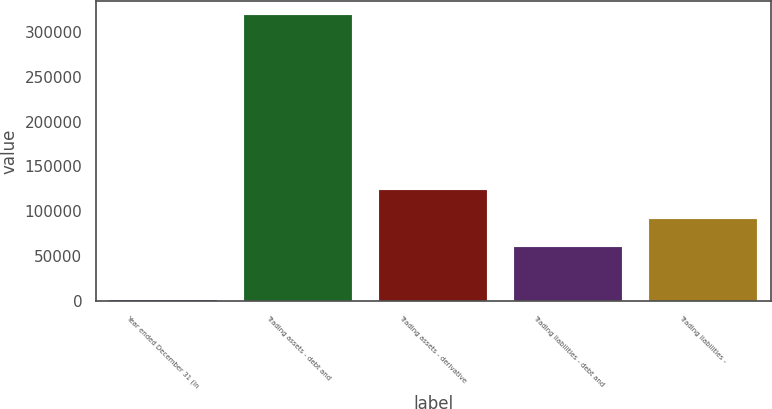Convert chart. <chart><loc_0><loc_0><loc_500><loc_500><bar_chart><fcel>Year ended December 31 (in<fcel>Trading assets - debt and<fcel>Trading assets - derivative<fcel>Trading liabilities - debt and<fcel>Trading liabilities -<nl><fcel>2009<fcel>318063<fcel>123435<fcel>60224<fcel>91829.4<nl></chart> 